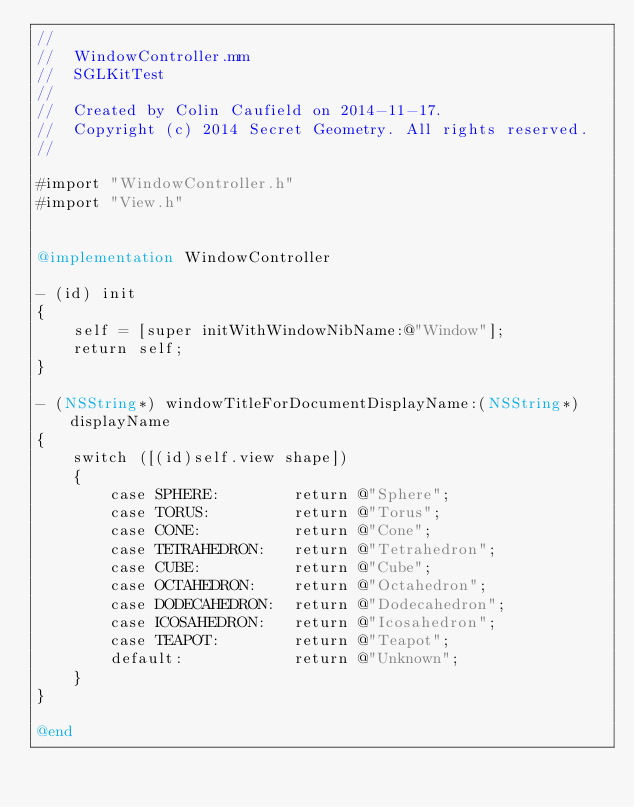Convert code to text. <code><loc_0><loc_0><loc_500><loc_500><_ObjectiveC_>//
//  WindowController.mm
//  SGLKitTest
//
//  Created by Colin Caufield on 2014-11-17.
//  Copyright (c) 2014 Secret Geometry. All rights reserved.
//

#import "WindowController.h"
#import "View.h"


@implementation WindowController

- (id) init
{
    self = [super initWithWindowNibName:@"Window"];
    return self;
}

- (NSString*) windowTitleForDocumentDisplayName:(NSString*)displayName
{
    switch ([(id)self.view shape])
    {
        case SPHERE:        return @"Sphere";
        case TORUS:         return @"Torus";
        case CONE:          return @"Cone";
        case TETRAHEDRON:   return @"Tetrahedron";
        case CUBE:          return @"Cube";
        case OCTAHEDRON:    return @"Octahedron";
        case DODECAHEDRON:  return @"Dodecahedron";
        case ICOSAHEDRON:   return @"Icosahedron";
        case TEAPOT:        return @"Teapot";
        default:            return @"Unknown";
    }
}

@end
</code> 